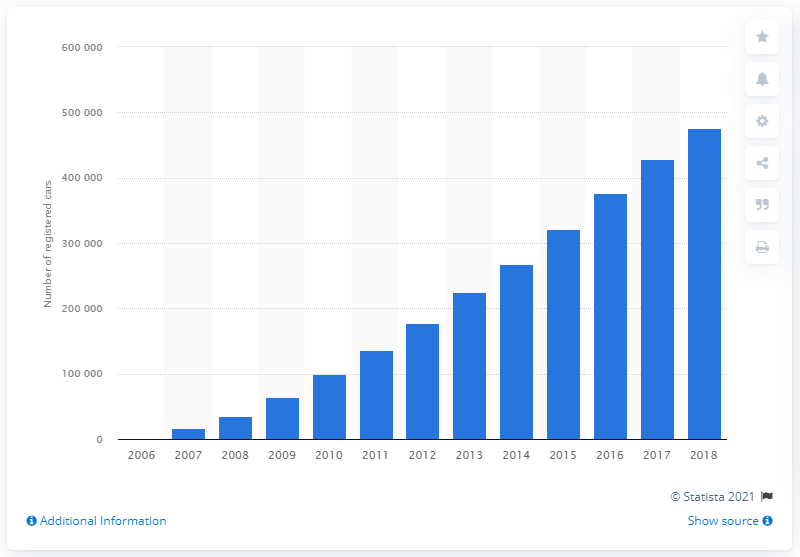Indicate a few pertinent items in this graphic. The Nissan Qashqai was one of the most popular car models in Britain in 2018. 